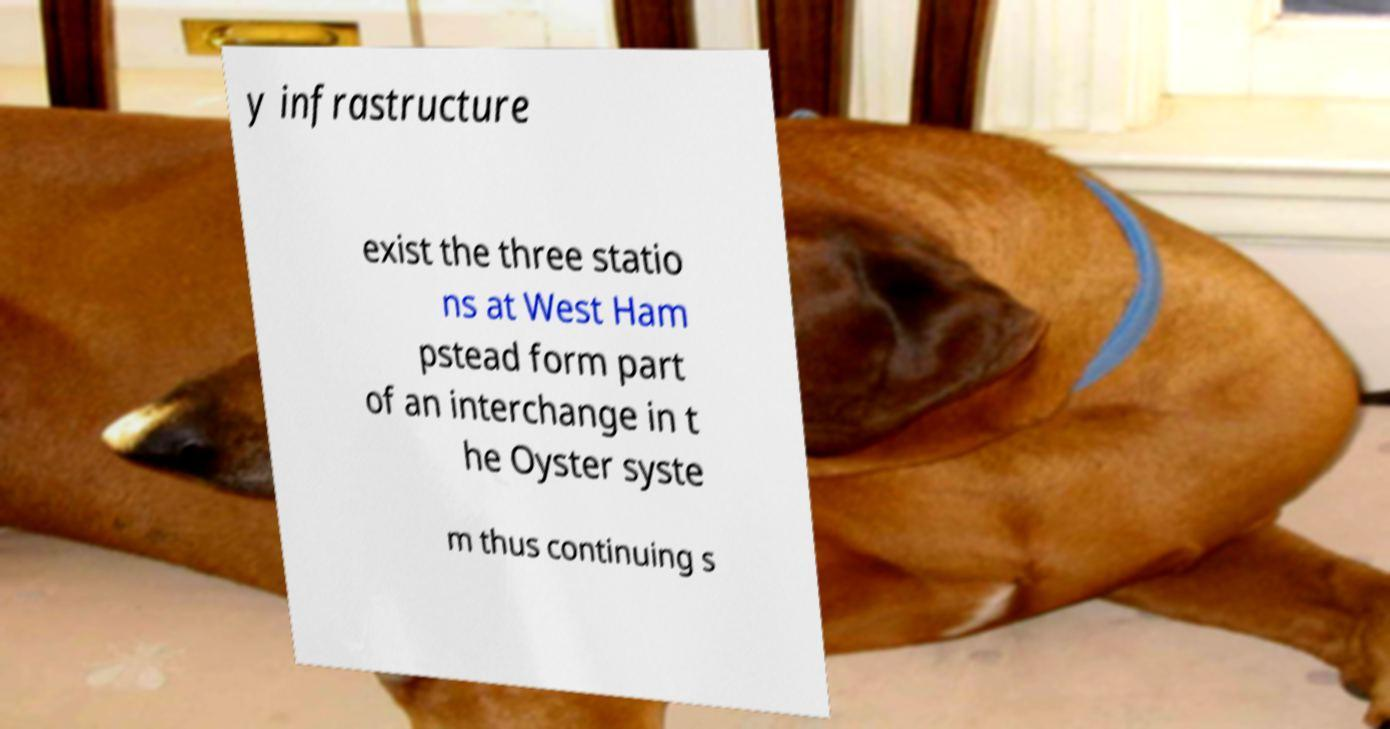For documentation purposes, I need the text within this image transcribed. Could you provide that? y infrastructure exist the three statio ns at West Ham pstead form part of an interchange in t he Oyster syste m thus continuing s 